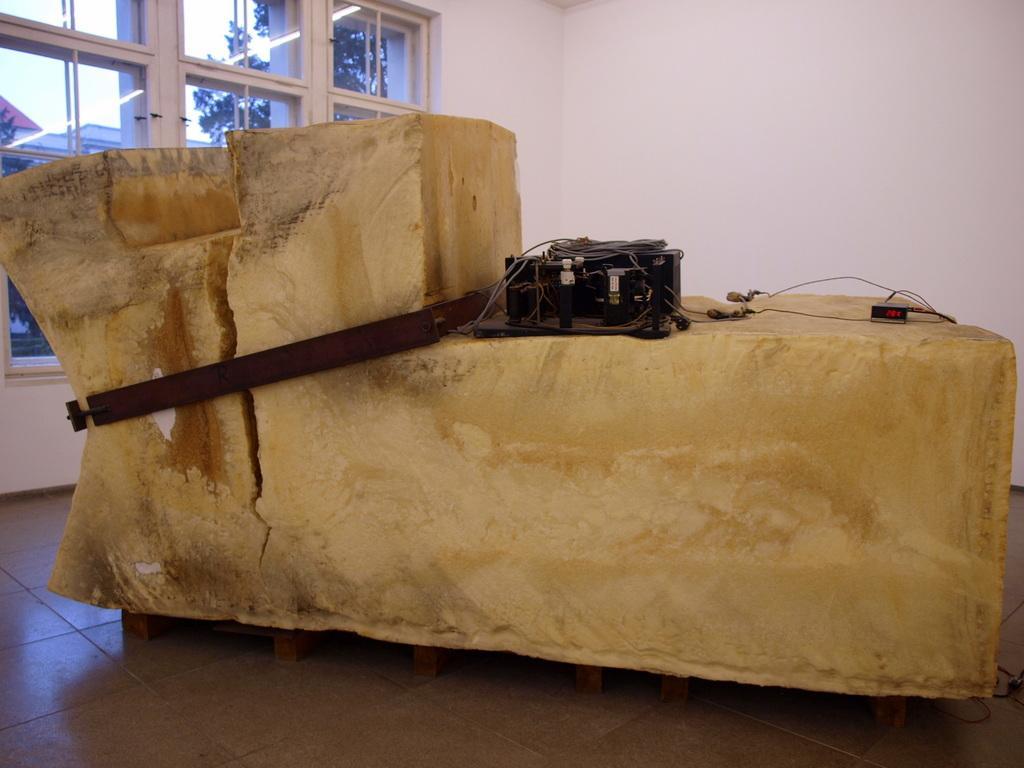Please provide a concise description of this image. There is a massive object kept on the floor,it is surrounded by an iron rod and some equipment is placed on the object. In the background there is a wall to the left side of the wall there is a window. 